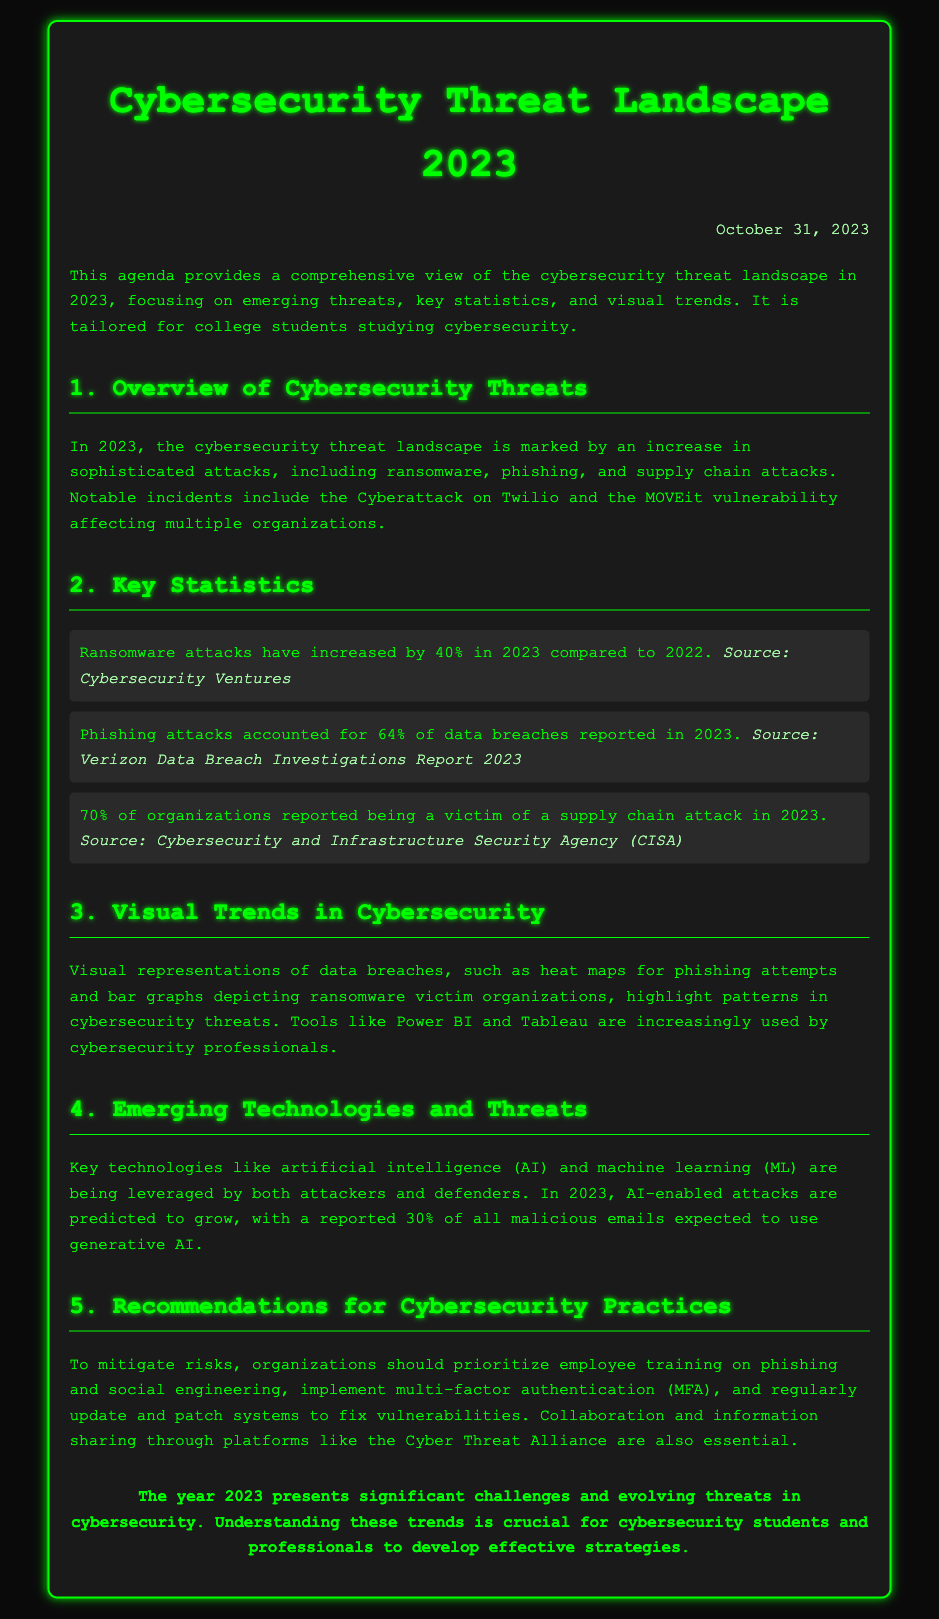What percentage increase in ransomware attacks was reported in 2023? The document states that ransomware attacks have increased by 40% in 2023 compared to 2022.
Answer: 40% What percentage of data breaches in 2023 were due to phishing? According to the document, phishing attacks accounted for 64% of data breaches reported in 2023.
Answer: 64% What did 70% of organizations report being a victim of in 2023? The document mentions that 70% of organizations reported being a victim of a supply chain attack in 2023.
Answer: Supply chain attack What emerging technology is predicted to grow in malicious emails in 2023? The document indicates that AI-enabled attacks are predicted to grow, with 30% of all malicious emails expected to use generative AI.
Answer: Generative AI What is recommended to mitigate risks related to phishing? The document recommends prioritizing employee training on phishing and social engineering to mitigate risks.
Answer: Employee training What type of visual representation is highlighted for phishing attempts? The document discusses heat maps as a visual representation for phishing attempts.
Answer: Heat maps What is the date specified in the document? The document states the date as October 31, 2023.
Answer: October 31, 2023 What is the source of the statistic about phishing attacks and data breaches? The document cites the Verizon Data Breach Investigations Report 2023 as the source for the phishing attacks statistic.
Answer: Verizon Data Breach Investigations Report 2023 What are cybersecurity professionals increasingly using for data visualization? According to the document, tools like Power BI and Tableau are increasingly used by cybersecurity professionals for data visualization.
Answer: Power BI and Tableau 